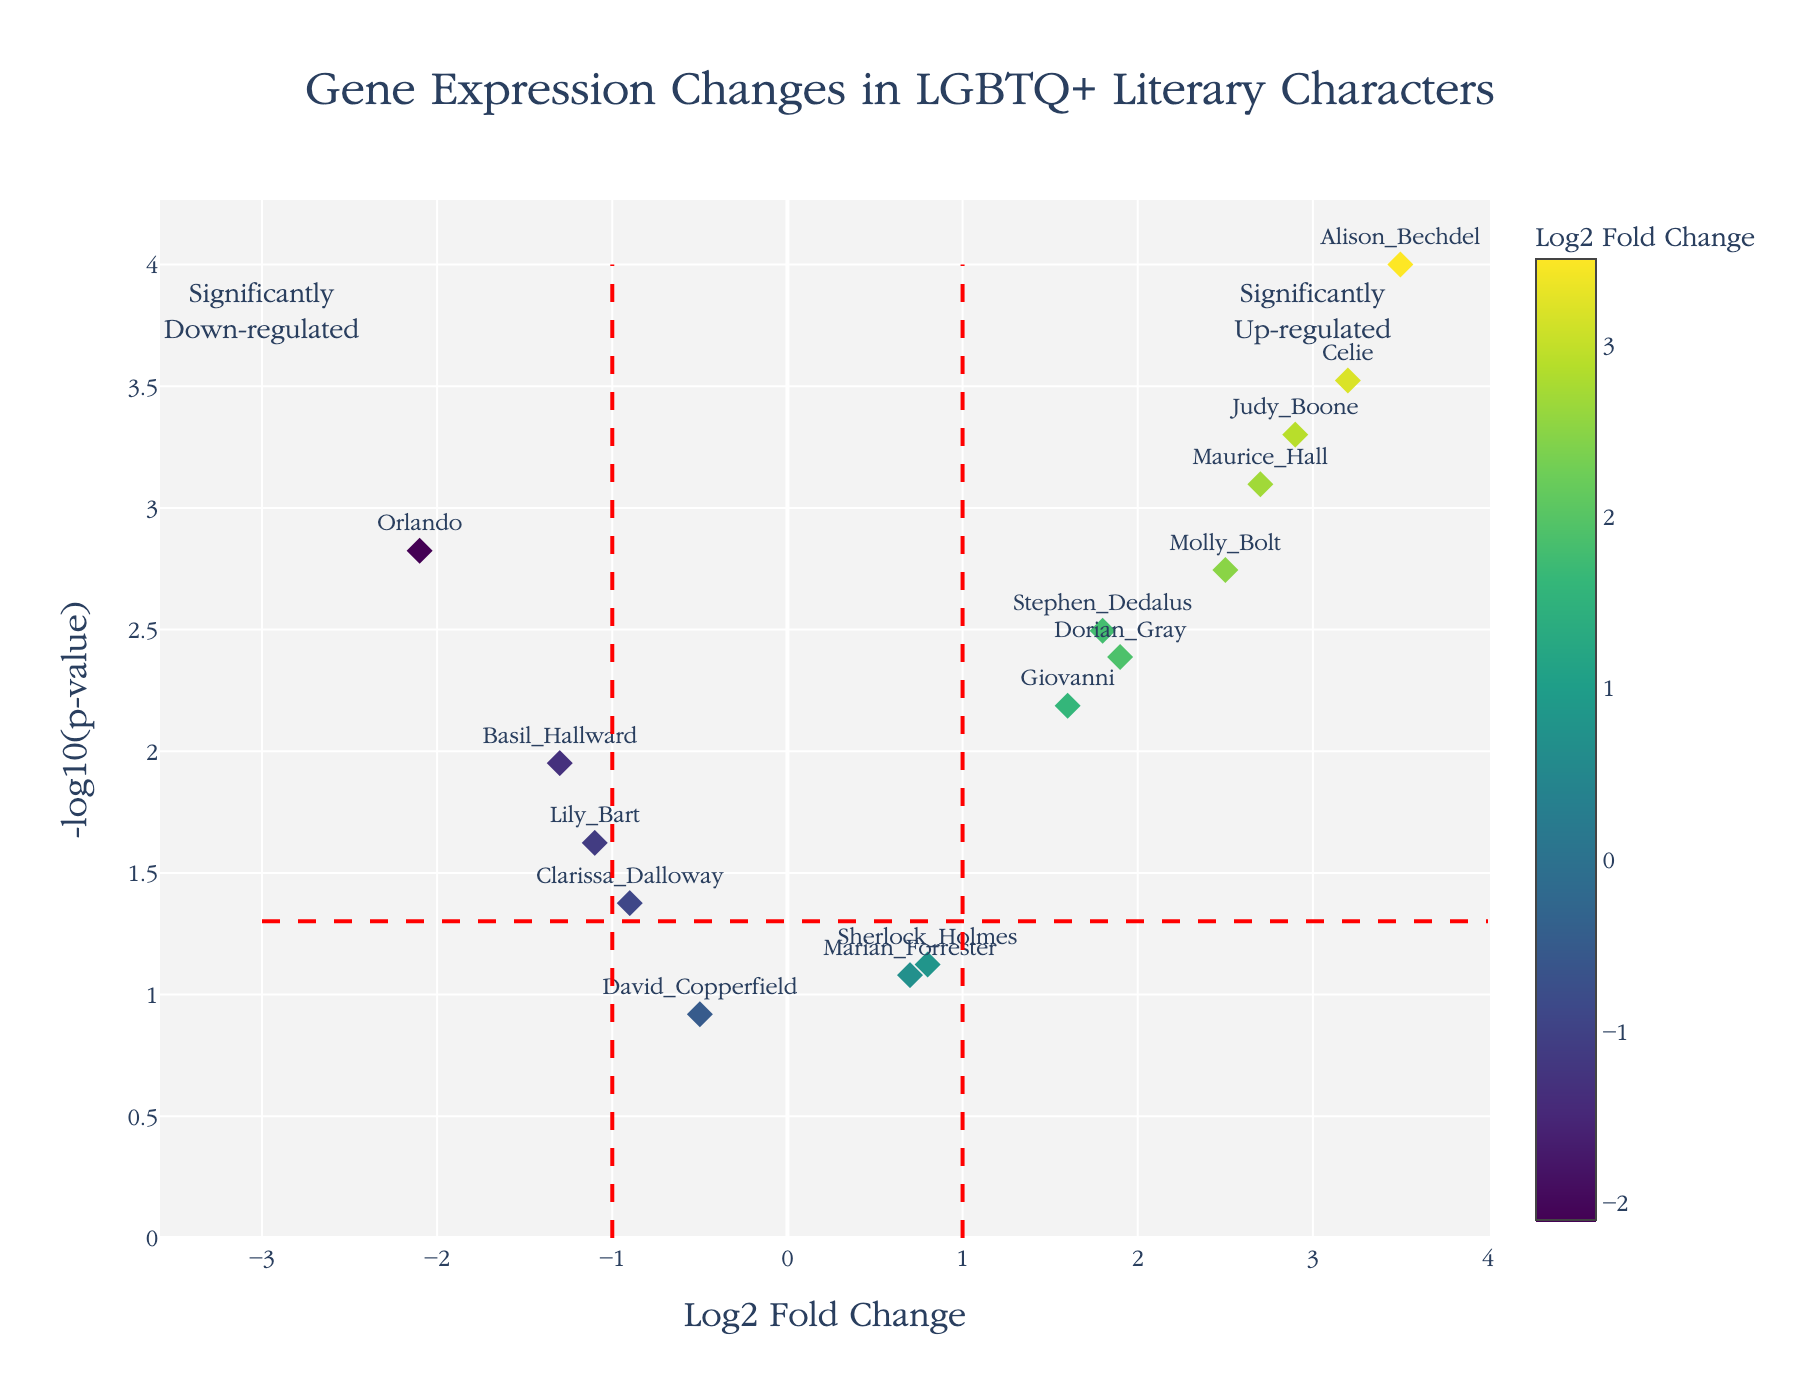What is the title of the plot? The title is displayed at the top center of the figure. It reads "Gene Expression Changes in LGBTQ+ Literary Characters".
Answer: Gene Expression Changes in LGBTQ+ Literary Characters How many characters have a Log2 Fold Change greater than 2? Identify data points with a Log2 Fold Change above the value of 2 on the x-axis. There are four characters: Maurice Hall, Celie, Molly Bolt, and Judy Boone.
Answer: 4 Which gene has the most significant p-value? The most significant p-value corresponds to the highest -log10(p-value) on the y-axis. Alison Bechdel has the highest -log10(p-value).
Answer: Alison Bechdel Is Dorian Gray up-regulated or down-regulated? Dorian Gray's Log2FoldChange is 1.9, on the right side (positive), indicating up-regulation.
Answer: Up-regulated What is the range of Log2 Fold Change displayed in the plot? The x-axis ranges from about -3 to about 4, encompassing the lowest to highest values of Log2 Fold Change.
Answer: -3 to 4 Which characters have a Log2 Fold Change within the range of -1 to 1 and a p-value significant enough to surpass the -log10(p-value) threshold line? Characters within -1 to 1 on Log2FC and above the horizontal red dashed line at 1.301 are: Clarissa Dalloway, Basil Hallward, Lily Bart, Stephen Dedalus.
Answer: Clarissa Dalloway, Basil Hallward, Lily Bart, Stephen Dedalus Which character has the smallest Log2 Fold Change and what is its value? The smallest Log2 Fold Change is to the far left on the x-axis, shown by Orlando with a value of -2.1.
Answer: Orlando, -2.1 How many characters fall into the significantly down-regulated category? Below the x= -1 and above the p-value threshold line represents significantly down-regulated genes. There are three characters: Orlando, Clarissa Dalloway, Basil Hallward, Lily Bart.
Answer: 4 Compare the p-values of Celie and Giovanni. Which one is more significant? Convert the p-values to -log10(p). Celie has a -log10(p) of 3.5229 while Giovanni has 2.1871. Celie is more significant.
Answer: Celie What element identifies a character's data point? Each data point is labeled by the character's name.
Answer: Character's name 